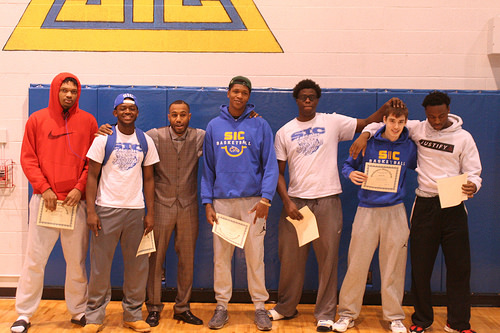<image>
Can you confirm if the person is next to the person? No. The person is not positioned next to the person. They are located in different areas of the scene. Where is the person in relation to the wall? Is it in front of the wall? Yes. The person is positioned in front of the wall, appearing closer to the camera viewpoint. 